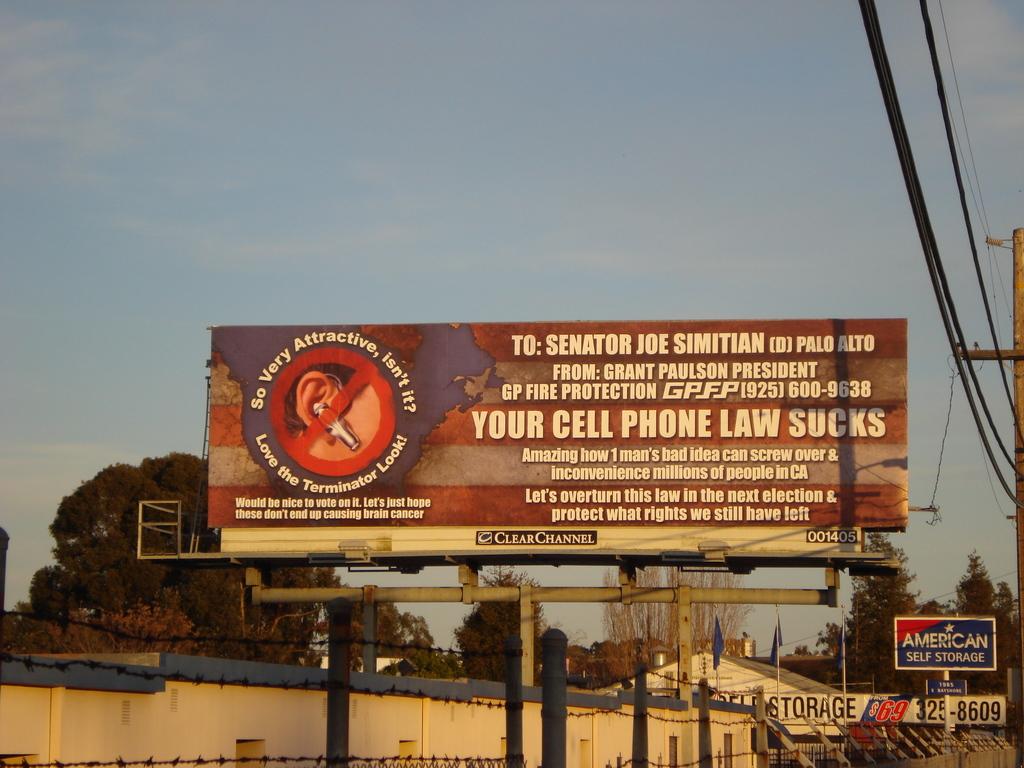Which senator is this addressed to?
Offer a very short reply. Joe simitian. 